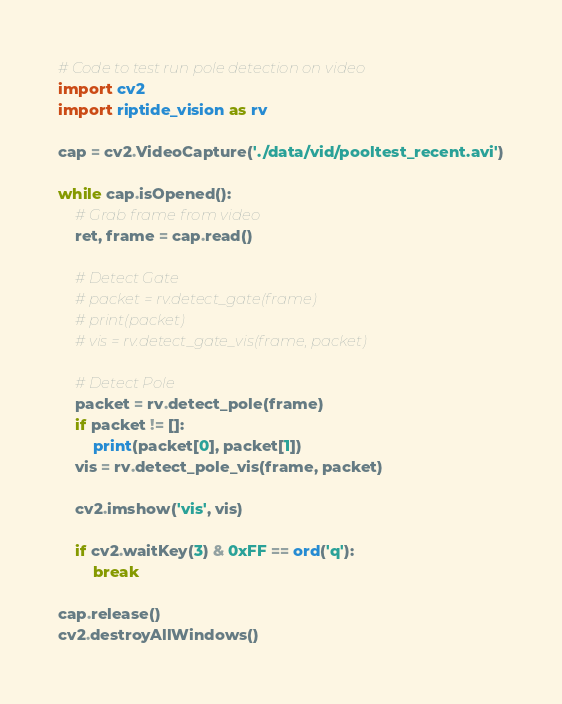Convert code to text. <code><loc_0><loc_0><loc_500><loc_500><_Python_># Code to test run pole detection on video
import cv2
import riptide_vision as rv

cap = cv2.VideoCapture('./data/vid/pooltest_recent.avi')

while cap.isOpened():
    # Grab frame from video
    ret, frame = cap.read()

    # Detect Gate
    # packet = rv.detect_gate(frame)
    # print(packet)
    # vis = rv.detect_gate_vis(frame, packet)

    # Detect Pole
    packet = rv.detect_pole(frame)
    if packet != []:
        print(packet[0], packet[1])
    vis = rv.detect_pole_vis(frame, packet)

    cv2.imshow('vis', vis)

    if cv2.waitKey(3) & 0xFF == ord('q'):
        break

cap.release()
cv2.destroyAllWindows()
</code> 